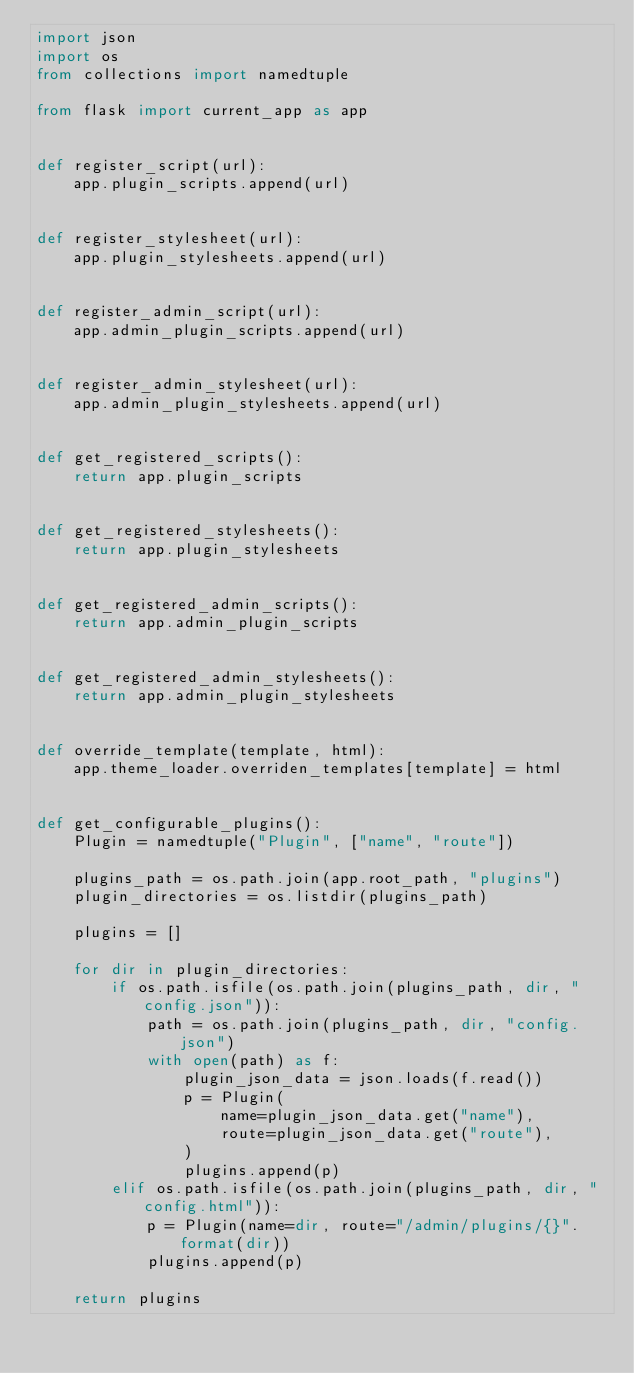Convert code to text. <code><loc_0><loc_0><loc_500><loc_500><_Python_>import json
import os
from collections import namedtuple

from flask import current_app as app


def register_script(url):
    app.plugin_scripts.append(url)


def register_stylesheet(url):
    app.plugin_stylesheets.append(url)


def register_admin_script(url):
    app.admin_plugin_scripts.append(url)


def register_admin_stylesheet(url):
    app.admin_plugin_stylesheets.append(url)


def get_registered_scripts():
    return app.plugin_scripts


def get_registered_stylesheets():
    return app.plugin_stylesheets


def get_registered_admin_scripts():
    return app.admin_plugin_scripts


def get_registered_admin_stylesheets():
    return app.admin_plugin_stylesheets


def override_template(template, html):
    app.theme_loader.overriden_templates[template] = html


def get_configurable_plugins():
    Plugin = namedtuple("Plugin", ["name", "route"])

    plugins_path = os.path.join(app.root_path, "plugins")
    plugin_directories = os.listdir(plugins_path)

    plugins = []

    for dir in plugin_directories:
        if os.path.isfile(os.path.join(plugins_path, dir, "config.json")):
            path = os.path.join(plugins_path, dir, "config.json")
            with open(path) as f:
                plugin_json_data = json.loads(f.read())
                p = Plugin(
                    name=plugin_json_data.get("name"),
                    route=plugin_json_data.get("route"),
                )
                plugins.append(p)
        elif os.path.isfile(os.path.join(plugins_path, dir, "config.html")):
            p = Plugin(name=dir, route="/admin/plugins/{}".format(dir))
            plugins.append(p)

    return plugins
</code> 